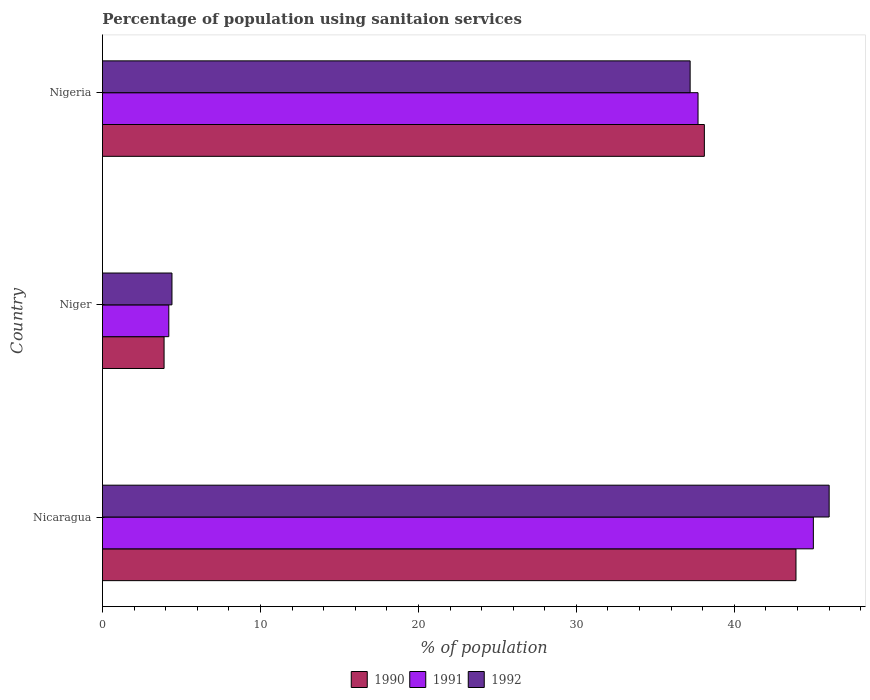How many groups of bars are there?
Offer a terse response. 3. Are the number of bars on each tick of the Y-axis equal?
Give a very brief answer. Yes. What is the label of the 3rd group of bars from the top?
Your answer should be compact. Nicaragua. What is the percentage of population using sanitaion services in 1992 in Nicaragua?
Your answer should be compact. 46. Across all countries, what is the maximum percentage of population using sanitaion services in 1992?
Give a very brief answer. 46. Across all countries, what is the minimum percentage of population using sanitaion services in 1991?
Make the answer very short. 4.2. In which country was the percentage of population using sanitaion services in 1991 maximum?
Provide a succinct answer. Nicaragua. In which country was the percentage of population using sanitaion services in 1992 minimum?
Provide a short and direct response. Niger. What is the total percentage of population using sanitaion services in 1991 in the graph?
Your answer should be very brief. 86.9. What is the difference between the percentage of population using sanitaion services in 1991 in Niger and that in Nigeria?
Give a very brief answer. -33.5. What is the difference between the percentage of population using sanitaion services in 1991 in Nicaragua and the percentage of population using sanitaion services in 1990 in Niger?
Ensure brevity in your answer.  41.1. What is the average percentage of population using sanitaion services in 1991 per country?
Ensure brevity in your answer.  28.97. What is the difference between the percentage of population using sanitaion services in 1992 and percentage of population using sanitaion services in 1990 in Niger?
Make the answer very short. 0.5. In how many countries, is the percentage of population using sanitaion services in 1991 greater than 14 %?
Provide a succinct answer. 2. What is the ratio of the percentage of population using sanitaion services in 1990 in Nicaragua to that in Nigeria?
Offer a very short reply. 1.15. Is the percentage of population using sanitaion services in 1992 in Niger less than that in Nigeria?
Make the answer very short. Yes. What is the difference between the highest and the second highest percentage of population using sanitaion services in 1990?
Provide a short and direct response. 5.8. What is the difference between the highest and the lowest percentage of population using sanitaion services in 1991?
Make the answer very short. 40.8. In how many countries, is the percentage of population using sanitaion services in 1991 greater than the average percentage of population using sanitaion services in 1991 taken over all countries?
Provide a succinct answer. 2. Is the sum of the percentage of population using sanitaion services in 1990 in Nicaragua and Niger greater than the maximum percentage of population using sanitaion services in 1991 across all countries?
Your answer should be compact. Yes. What does the 2nd bar from the bottom in Niger represents?
Make the answer very short. 1991. How many bars are there?
Provide a succinct answer. 9. Are all the bars in the graph horizontal?
Make the answer very short. Yes. How many countries are there in the graph?
Offer a very short reply. 3. What is the difference between two consecutive major ticks on the X-axis?
Provide a short and direct response. 10. Does the graph contain any zero values?
Keep it short and to the point. No. Where does the legend appear in the graph?
Give a very brief answer. Bottom center. What is the title of the graph?
Ensure brevity in your answer.  Percentage of population using sanitaion services. Does "1972" appear as one of the legend labels in the graph?
Your answer should be compact. No. What is the label or title of the X-axis?
Keep it short and to the point. % of population. What is the % of population of 1990 in Nicaragua?
Keep it short and to the point. 43.9. What is the % of population of 1992 in Nicaragua?
Provide a succinct answer. 46. What is the % of population in 1990 in Niger?
Provide a succinct answer. 3.9. What is the % of population of 1991 in Niger?
Make the answer very short. 4.2. What is the % of population in 1990 in Nigeria?
Provide a succinct answer. 38.1. What is the % of population of 1991 in Nigeria?
Give a very brief answer. 37.7. What is the % of population of 1992 in Nigeria?
Provide a succinct answer. 37.2. Across all countries, what is the maximum % of population in 1990?
Ensure brevity in your answer.  43.9. Across all countries, what is the maximum % of population of 1992?
Your answer should be very brief. 46. Across all countries, what is the minimum % of population of 1990?
Give a very brief answer. 3.9. What is the total % of population in 1990 in the graph?
Your answer should be very brief. 85.9. What is the total % of population of 1991 in the graph?
Your response must be concise. 86.9. What is the total % of population of 1992 in the graph?
Provide a succinct answer. 87.6. What is the difference between the % of population in 1990 in Nicaragua and that in Niger?
Your answer should be very brief. 40. What is the difference between the % of population in 1991 in Nicaragua and that in Niger?
Offer a terse response. 40.8. What is the difference between the % of population in 1992 in Nicaragua and that in Niger?
Make the answer very short. 41.6. What is the difference between the % of population in 1990 in Nicaragua and that in Nigeria?
Your answer should be very brief. 5.8. What is the difference between the % of population of 1990 in Niger and that in Nigeria?
Your response must be concise. -34.2. What is the difference between the % of population of 1991 in Niger and that in Nigeria?
Provide a short and direct response. -33.5. What is the difference between the % of population of 1992 in Niger and that in Nigeria?
Your response must be concise. -32.8. What is the difference between the % of population in 1990 in Nicaragua and the % of population in 1991 in Niger?
Your answer should be compact. 39.7. What is the difference between the % of population of 1990 in Nicaragua and the % of population of 1992 in Niger?
Provide a succinct answer. 39.5. What is the difference between the % of population of 1991 in Nicaragua and the % of population of 1992 in Niger?
Make the answer very short. 40.6. What is the difference between the % of population in 1990 in Nicaragua and the % of population in 1991 in Nigeria?
Ensure brevity in your answer.  6.2. What is the difference between the % of population of 1991 in Nicaragua and the % of population of 1992 in Nigeria?
Ensure brevity in your answer.  7.8. What is the difference between the % of population in 1990 in Niger and the % of population in 1991 in Nigeria?
Provide a short and direct response. -33.8. What is the difference between the % of population of 1990 in Niger and the % of population of 1992 in Nigeria?
Give a very brief answer. -33.3. What is the difference between the % of population of 1991 in Niger and the % of population of 1992 in Nigeria?
Offer a terse response. -33. What is the average % of population of 1990 per country?
Make the answer very short. 28.63. What is the average % of population of 1991 per country?
Your answer should be very brief. 28.97. What is the average % of population in 1992 per country?
Your answer should be compact. 29.2. What is the difference between the % of population of 1990 and % of population of 1992 in Nicaragua?
Offer a terse response. -2.1. What is the difference between the % of population in 1990 and % of population in 1991 in Niger?
Provide a succinct answer. -0.3. What is the difference between the % of population of 1990 and % of population of 1992 in Niger?
Make the answer very short. -0.5. What is the difference between the % of population in 1991 and % of population in 1992 in Nigeria?
Your response must be concise. 0.5. What is the ratio of the % of population in 1990 in Nicaragua to that in Niger?
Offer a terse response. 11.26. What is the ratio of the % of population of 1991 in Nicaragua to that in Niger?
Give a very brief answer. 10.71. What is the ratio of the % of population in 1992 in Nicaragua to that in Niger?
Provide a succinct answer. 10.45. What is the ratio of the % of population in 1990 in Nicaragua to that in Nigeria?
Provide a succinct answer. 1.15. What is the ratio of the % of population of 1991 in Nicaragua to that in Nigeria?
Give a very brief answer. 1.19. What is the ratio of the % of population in 1992 in Nicaragua to that in Nigeria?
Your response must be concise. 1.24. What is the ratio of the % of population in 1990 in Niger to that in Nigeria?
Give a very brief answer. 0.1. What is the ratio of the % of population of 1991 in Niger to that in Nigeria?
Provide a succinct answer. 0.11. What is the ratio of the % of population of 1992 in Niger to that in Nigeria?
Make the answer very short. 0.12. What is the difference between the highest and the second highest % of population of 1991?
Your answer should be very brief. 7.3. What is the difference between the highest and the second highest % of population of 1992?
Ensure brevity in your answer.  8.8. What is the difference between the highest and the lowest % of population in 1991?
Your answer should be compact. 40.8. What is the difference between the highest and the lowest % of population in 1992?
Provide a succinct answer. 41.6. 